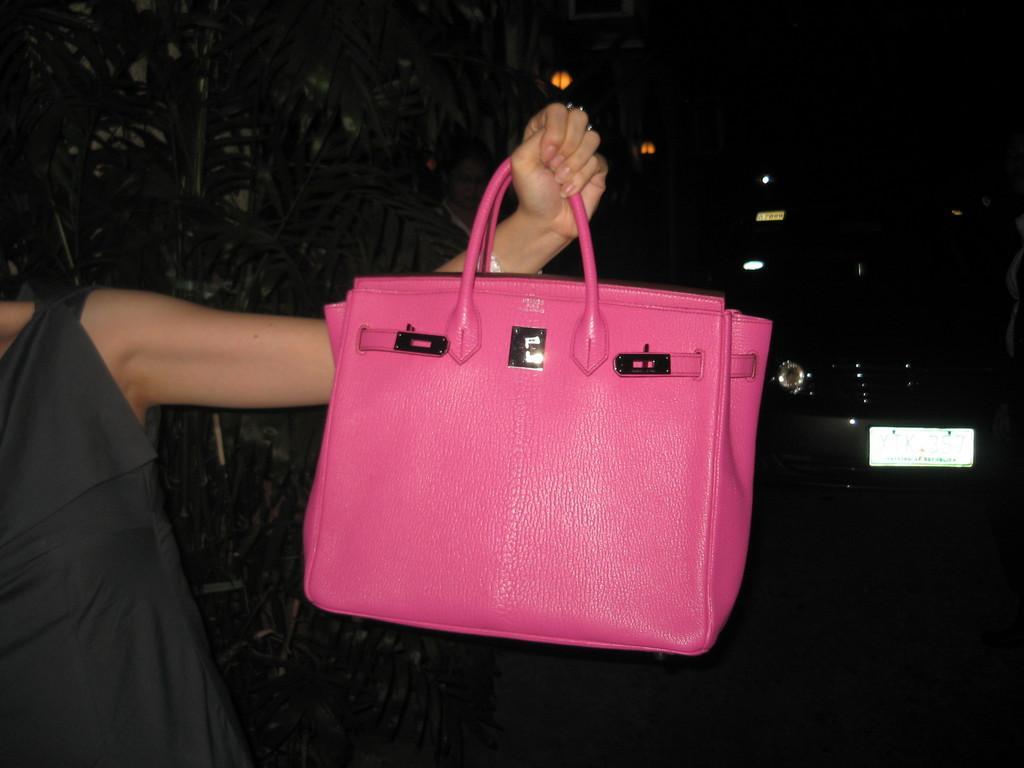Can you describe this image briefly? This pink color handbag is highlighted in this picture. This woman is holding this pink color handbag. These are plants. Beside this plants a woman is standing. A vehicle. 